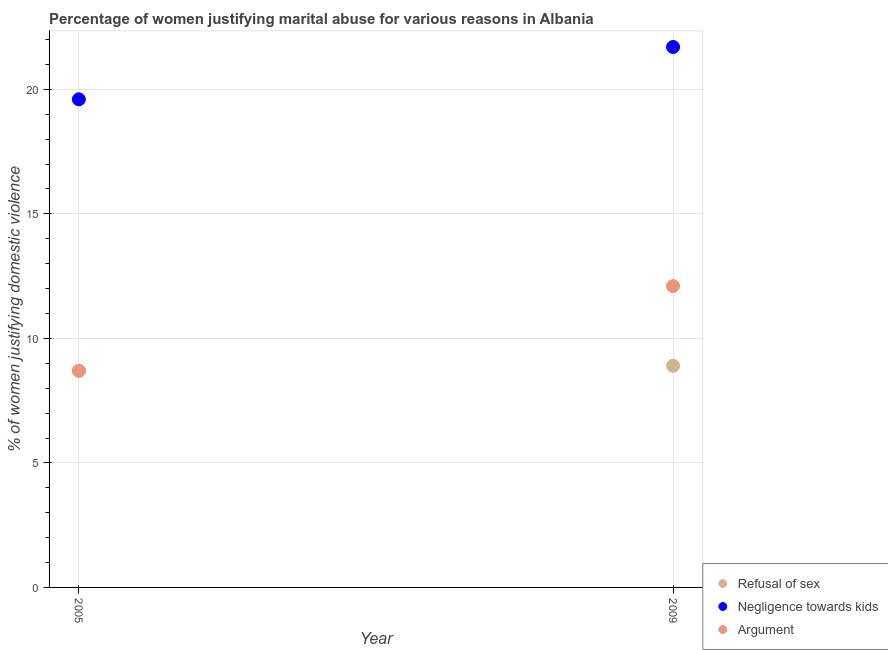How many different coloured dotlines are there?
Your response must be concise. 3. Is the number of dotlines equal to the number of legend labels?
Ensure brevity in your answer.  Yes. What is the percentage of women justifying domestic violence due to negligence towards kids in 2005?
Your response must be concise. 19.6. Across all years, what is the minimum percentage of women justifying domestic violence due to arguments?
Make the answer very short. 8.7. In which year was the percentage of women justifying domestic violence due to refusal of sex maximum?
Your answer should be compact. 2009. In which year was the percentage of women justifying domestic violence due to refusal of sex minimum?
Offer a very short reply. 2005. What is the difference between the percentage of women justifying domestic violence due to arguments in 2005 and that in 2009?
Ensure brevity in your answer.  -3.4. What is the average percentage of women justifying domestic violence due to negligence towards kids per year?
Offer a terse response. 20.65. In the year 2009, what is the difference between the percentage of women justifying domestic violence due to negligence towards kids and percentage of women justifying domestic violence due to refusal of sex?
Your response must be concise. 12.8. In how many years, is the percentage of women justifying domestic violence due to refusal of sex greater than 21 %?
Make the answer very short. 0. What is the ratio of the percentage of women justifying domestic violence due to negligence towards kids in 2005 to that in 2009?
Your answer should be compact. 0.9. Is it the case that in every year, the sum of the percentage of women justifying domestic violence due to refusal of sex and percentage of women justifying domestic violence due to negligence towards kids is greater than the percentage of women justifying domestic violence due to arguments?
Ensure brevity in your answer.  Yes. Are the values on the major ticks of Y-axis written in scientific E-notation?
Ensure brevity in your answer.  No. How many legend labels are there?
Your answer should be very brief. 3. What is the title of the graph?
Keep it short and to the point. Percentage of women justifying marital abuse for various reasons in Albania. What is the label or title of the X-axis?
Make the answer very short. Year. What is the label or title of the Y-axis?
Provide a succinct answer. % of women justifying domestic violence. What is the % of women justifying domestic violence in Refusal of sex in 2005?
Your answer should be compact. 8.7. What is the % of women justifying domestic violence in Negligence towards kids in 2005?
Your answer should be very brief. 19.6. What is the % of women justifying domestic violence of Argument in 2005?
Provide a short and direct response. 8.7. What is the % of women justifying domestic violence in Refusal of sex in 2009?
Your response must be concise. 8.9. What is the % of women justifying domestic violence of Negligence towards kids in 2009?
Provide a short and direct response. 21.7. What is the % of women justifying domestic violence of Argument in 2009?
Offer a very short reply. 12.1. Across all years, what is the maximum % of women justifying domestic violence in Refusal of sex?
Offer a very short reply. 8.9. Across all years, what is the maximum % of women justifying domestic violence of Negligence towards kids?
Ensure brevity in your answer.  21.7. Across all years, what is the maximum % of women justifying domestic violence in Argument?
Your response must be concise. 12.1. Across all years, what is the minimum % of women justifying domestic violence of Negligence towards kids?
Your answer should be compact. 19.6. What is the total % of women justifying domestic violence of Refusal of sex in the graph?
Ensure brevity in your answer.  17.6. What is the total % of women justifying domestic violence of Negligence towards kids in the graph?
Your answer should be very brief. 41.3. What is the total % of women justifying domestic violence in Argument in the graph?
Provide a short and direct response. 20.8. What is the difference between the % of women justifying domestic violence in Negligence towards kids in 2005 and that in 2009?
Ensure brevity in your answer.  -2.1. What is the difference between the % of women justifying domestic violence of Refusal of sex in 2005 and the % of women justifying domestic violence of Negligence towards kids in 2009?
Keep it short and to the point. -13. What is the average % of women justifying domestic violence in Refusal of sex per year?
Offer a terse response. 8.8. What is the average % of women justifying domestic violence of Negligence towards kids per year?
Offer a very short reply. 20.65. What is the average % of women justifying domestic violence in Argument per year?
Your response must be concise. 10.4. In the year 2005, what is the difference between the % of women justifying domestic violence in Refusal of sex and % of women justifying domestic violence in Negligence towards kids?
Give a very brief answer. -10.9. In the year 2009, what is the difference between the % of women justifying domestic violence in Refusal of sex and % of women justifying domestic violence in Negligence towards kids?
Offer a very short reply. -12.8. What is the ratio of the % of women justifying domestic violence of Refusal of sex in 2005 to that in 2009?
Your response must be concise. 0.98. What is the ratio of the % of women justifying domestic violence in Negligence towards kids in 2005 to that in 2009?
Give a very brief answer. 0.9. What is the ratio of the % of women justifying domestic violence in Argument in 2005 to that in 2009?
Give a very brief answer. 0.72. What is the difference between the highest and the lowest % of women justifying domestic violence of Argument?
Your answer should be very brief. 3.4. 